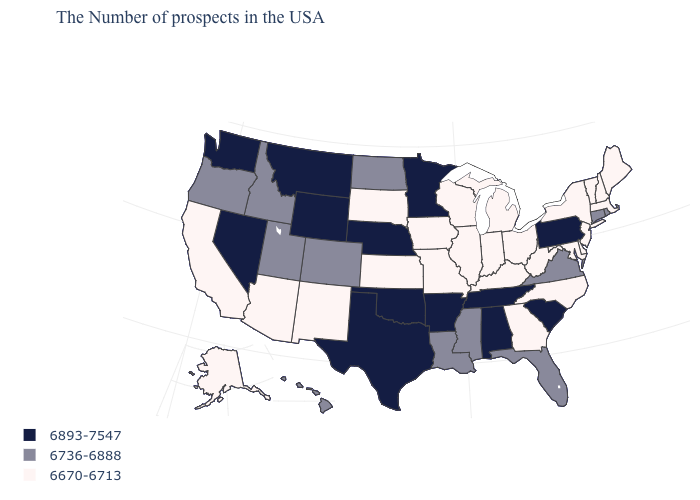Name the states that have a value in the range 6670-6713?
Concise answer only. Maine, Massachusetts, New Hampshire, Vermont, New York, New Jersey, Delaware, Maryland, North Carolina, West Virginia, Ohio, Georgia, Michigan, Kentucky, Indiana, Wisconsin, Illinois, Missouri, Iowa, Kansas, South Dakota, New Mexico, Arizona, California, Alaska. Among the states that border West Virginia , which have the lowest value?
Write a very short answer. Maryland, Ohio, Kentucky. Among the states that border North Carolina , does Georgia have the lowest value?
Short answer required. Yes. Is the legend a continuous bar?
Keep it brief. No. What is the value of Kentucky?
Give a very brief answer. 6670-6713. What is the value of Florida?
Write a very short answer. 6736-6888. Does Washington have the same value as Oregon?
Quick response, please. No. Among the states that border Wyoming , which have the highest value?
Keep it brief. Nebraska, Montana. Does North Carolina have the lowest value in the USA?
Quick response, please. Yes. Name the states that have a value in the range 6670-6713?
Write a very short answer. Maine, Massachusetts, New Hampshire, Vermont, New York, New Jersey, Delaware, Maryland, North Carolina, West Virginia, Ohio, Georgia, Michigan, Kentucky, Indiana, Wisconsin, Illinois, Missouri, Iowa, Kansas, South Dakota, New Mexico, Arizona, California, Alaska. Among the states that border Florida , does Georgia have the highest value?
Be succinct. No. Does Montana have the highest value in the West?
Concise answer only. Yes. What is the value of Rhode Island?
Short answer required. 6736-6888. Name the states that have a value in the range 6893-7547?
Quick response, please. Pennsylvania, South Carolina, Alabama, Tennessee, Arkansas, Minnesota, Nebraska, Oklahoma, Texas, Wyoming, Montana, Nevada, Washington. Name the states that have a value in the range 6893-7547?
Short answer required. Pennsylvania, South Carolina, Alabama, Tennessee, Arkansas, Minnesota, Nebraska, Oklahoma, Texas, Wyoming, Montana, Nevada, Washington. 